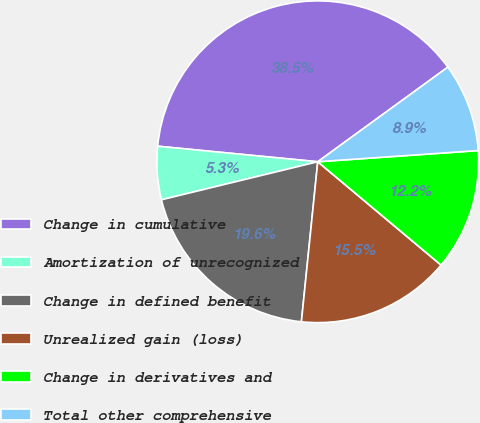Convert chart. <chart><loc_0><loc_0><loc_500><loc_500><pie_chart><fcel>Change in cumulative<fcel>Amortization of unrecognized<fcel>Change in defined benefit<fcel>Unrealized gain (loss)<fcel>Change in derivatives and<fcel>Total other comprehensive<nl><fcel>38.45%<fcel>5.34%<fcel>19.58%<fcel>15.52%<fcel>12.21%<fcel>8.9%<nl></chart> 